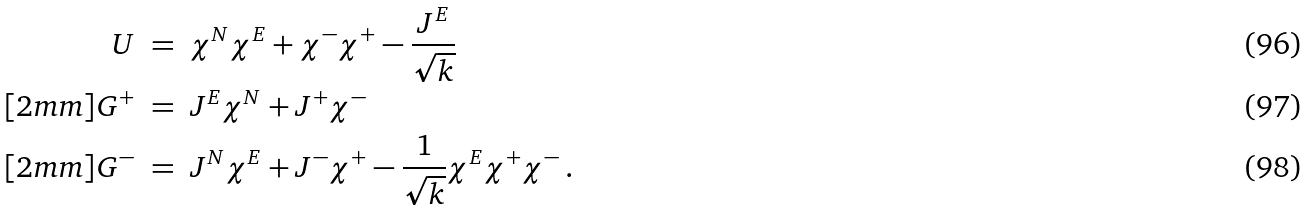Convert formula to latex. <formula><loc_0><loc_0><loc_500><loc_500>U \ & = \ \chi ^ { N } \chi ^ { E } + \chi ^ { - } \chi ^ { + } - \frac { J ^ { E } } { \sqrt { k } } \\ [ 2 m m ] G ^ { + } \ & = \ J ^ { E } \chi ^ { N } + J ^ { + } \chi ^ { - } \\ [ 2 m m ] G ^ { - } \ & = \ J ^ { N } \chi ^ { E } + J ^ { - } \chi ^ { + } - \frac { 1 } { \sqrt { k } } \chi ^ { E } \chi ^ { + } \chi ^ { - } \, .</formula> 